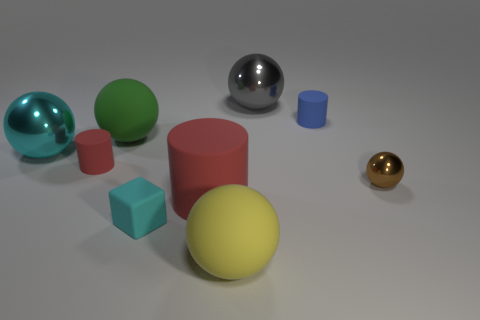Subtract all cyan shiny spheres. How many spheres are left? 4 Subtract all brown spheres. How many spheres are left? 4 Subtract all red balls. Subtract all yellow blocks. How many balls are left? 5 Subtract all blocks. How many objects are left? 8 Subtract 0 red blocks. How many objects are left? 9 Subtract all tiny gray shiny objects. Subtract all cyan objects. How many objects are left? 7 Add 9 tiny cyan matte blocks. How many tiny cyan matte blocks are left? 10 Add 9 large brown cubes. How many large brown cubes exist? 9 